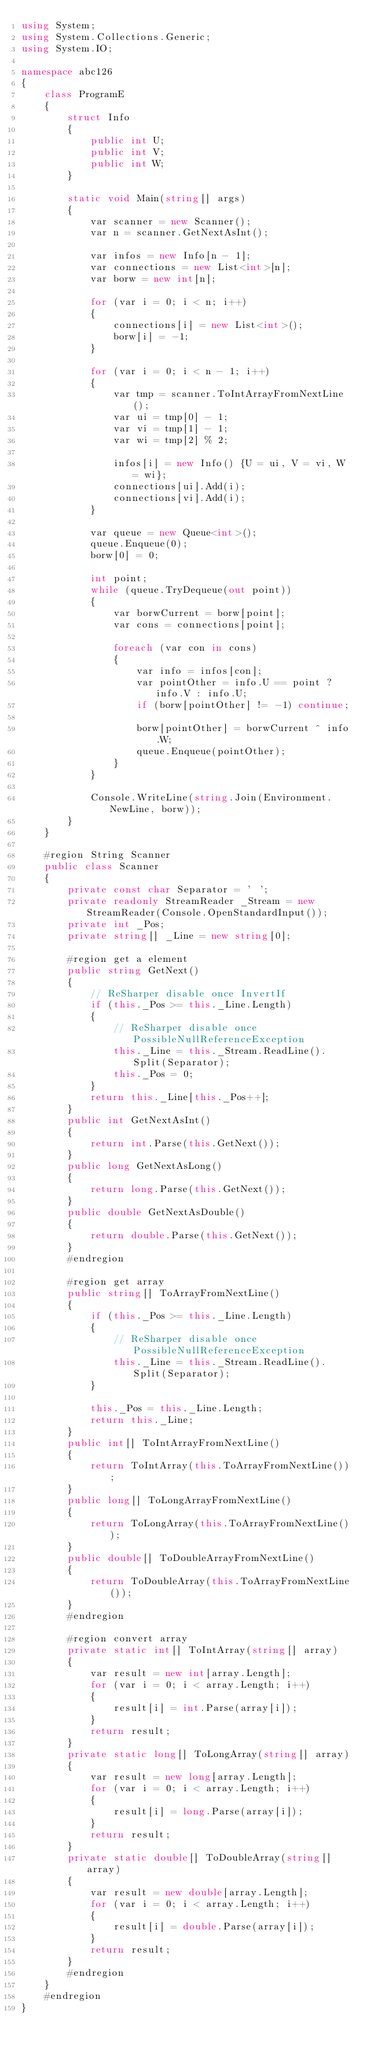Convert code to text. <code><loc_0><loc_0><loc_500><loc_500><_C#_>using System;
using System.Collections.Generic;
using System.IO;

namespace abc126
{
    class ProgramE
    {
        struct Info
        {
            public int U;
            public int V;
            public int W;
        }

        static void Main(string[] args)
        {
            var scanner = new Scanner();
            var n = scanner.GetNextAsInt();

            var infos = new Info[n - 1];
            var connections = new List<int>[n];
            var borw = new int[n];

            for (var i = 0; i < n; i++)
            {
                connections[i] = new List<int>();
                borw[i] = -1;
            }

            for (var i = 0; i < n - 1; i++)
            {
                var tmp = scanner.ToIntArrayFromNextLine();
                var ui = tmp[0] - 1;
                var vi = tmp[1] - 1;
                var wi = tmp[2] % 2;

                infos[i] = new Info() {U = ui, V = vi, W = wi};
                connections[ui].Add(i);
                connections[vi].Add(i);
            }

            var queue = new Queue<int>();
            queue.Enqueue(0);
            borw[0] = 0;

            int point;
            while (queue.TryDequeue(out point))
            {
                var borwCurrent = borw[point];
                var cons = connections[point];

                foreach (var con in cons)
                {
                    var info = infos[con];
                    var pointOther = info.U == point ? info.V : info.U;
                    if (borw[pointOther] != -1) continue;

                    borw[pointOther] = borwCurrent ^ info.W;
                    queue.Enqueue(pointOther);
                }
            }

            Console.WriteLine(string.Join(Environment.NewLine, borw));
        }
    }

    #region String Scanner
    public class Scanner
    {
        private const char Separator = ' ';
        private readonly StreamReader _Stream = new StreamReader(Console.OpenStandardInput());
        private int _Pos;
        private string[] _Line = new string[0];

        #region get a element
        public string GetNext()
        {
            // ReSharper disable once InvertIf
            if (this._Pos >= this._Line.Length)
            {
                // ReSharper disable once PossibleNullReferenceException
                this._Line = this._Stream.ReadLine().Split(Separator);
                this._Pos = 0;
            }
            return this._Line[this._Pos++];
        }
        public int GetNextAsInt()
        {
            return int.Parse(this.GetNext());
        }
        public long GetNextAsLong()
        {
            return long.Parse(this.GetNext());
        }
        public double GetNextAsDouble()
        {
            return double.Parse(this.GetNext());
        }
        #endregion

        #region get array
        public string[] ToArrayFromNextLine()
        {
            if (this._Pos >= this._Line.Length)
            {
                // ReSharper disable once PossibleNullReferenceException
                this._Line = this._Stream.ReadLine().Split(Separator);
            }

            this._Pos = this._Line.Length;
            return this._Line;
        }
        public int[] ToIntArrayFromNextLine()
        {
            return ToIntArray(this.ToArrayFromNextLine());
        }
        public long[] ToLongArrayFromNextLine()
        {
            return ToLongArray(this.ToArrayFromNextLine());
        }
        public double[] ToDoubleArrayFromNextLine()
        {
            return ToDoubleArray(this.ToArrayFromNextLine());
        }
        #endregion

        #region convert array
        private static int[] ToIntArray(string[] array)
        {
            var result = new int[array.Length];
            for (var i = 0; i < array.Length; i++)
            {
                result[i] = int.Parse(array[i]);
            }
            return result;
        }
        private static long[] ToLongArray(string[] array)
        {
            var result = new long[array.Length];
            for (var i = 0; i < array.Length; i++)
            {
                result[i] = long.Parse(array[i]);
            }
            return result;
        }
        private static double[] ToDoubleArray(string[] array)
        {
            var result = new double[array.Length];
            for (var i = 0; i < array.Length; i++)
            {
                result[i] = double.Parse(array[i]);
            }
            return result;
        }
        #endregion
    }
    #endregion
}
</code> 